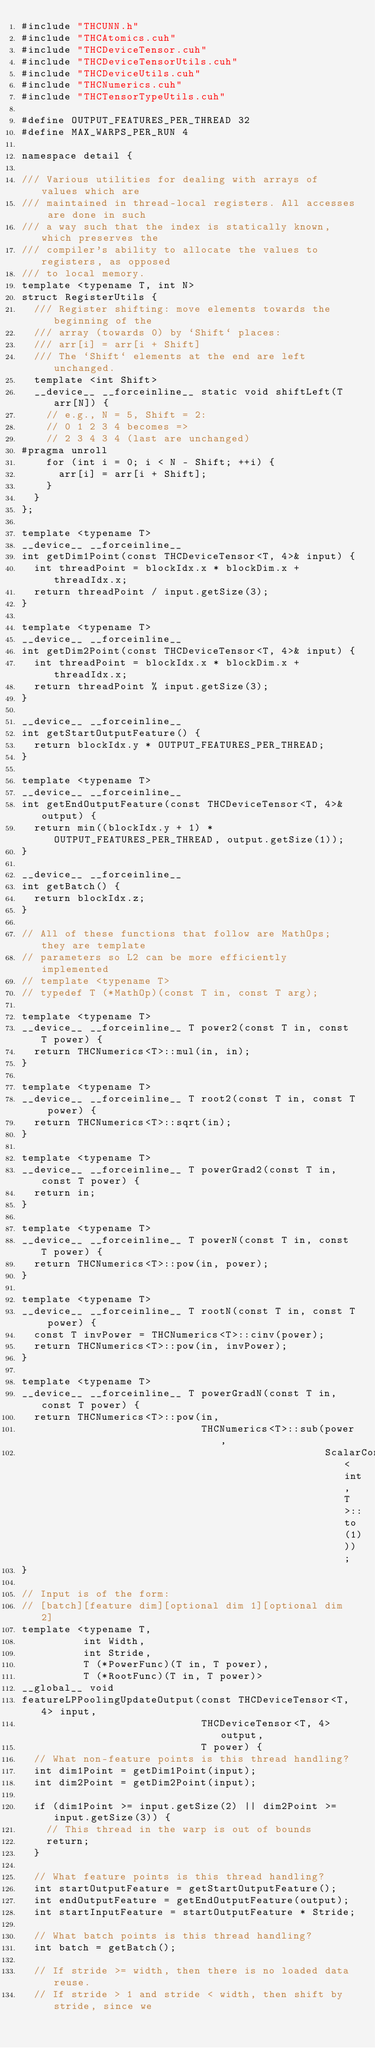<code> <loc_0><loc_0><loc_500><loc_500><_Cuda_>#include "THCUNN.h"
#include "THCAtomics.cuh"
#include "THCDeviceTensor.cuh"
#include "THCDeviceTensorUtils.cuh"
#include "THCDeviceUtils.cuh"
#include "THCNumerics.cuh"
#include "THCTensorTypeUtils.cuh"

#define OUTPUT_FEATURES_PER_THREAD 32
#define MAX_WARPS_PER_RUN 4

namespace detail {

/// Various utilities for dealing with arrays of values which are
/// maintained in thread-local registers. All accesses are done in such
/// a way such that the index is statically known, which preserves the
/// compiler's ability to allocate the values to registers, as opposed
/// to local memory.
template <typename T, int N>
struct RegisterUtils {
  /// Register shifting: move elements towards the beginning of the
  /// array (towards 0) by `Shift` places:
  /// arr[i] = arr[i + Shift]
  /// The `Shift` elements at the end are left unchanged.
  template <int Shift>
  __device__ __forceinline__ static void shiftLeft(T arr[N]) {
    // e.g., N = 5, Shift = 2:
    // 0 1 2 3 4 becomes =>
    // 2 3 4 3 4 (last are unchanged)
#pragma unroll
    for (int i = 0; i < N - Shift; ++i) {
      arr[i] = arr[i + Shift];
    }
  }
};

template <typename T>
__device__ __forceinline__
int getDim1Point(const THCDeviceTensor<T, 4>& input) {
  int threadPoint = blockIdx.x * blockDim.x + threadIdx.x;
  return threadPoint / input.getSize(3);
}

template <typename T>
__device__ __forceinline__
int getDim2Point(const THCDeviceTensor<T, 4>& input) {
  int threadPoint = blockIdx.x * blockDim.x + threadIdx.x;
  return threadPoint % input.getSize(3);
}

__device__ __forceinline__
int getStartOutputFeature() {
  return blockIdx.y * OUTPUT_FEATURES_PER_THREAD;
}

template <typename T>
__device__ __forceinline__
int getEndOutputFeature(const THCDeviceTensor<T, 4>& output) {
  return min((blockIdx.y + 1) * OUTPUT_FEATURES_PER_THREAD, output.getSize(1));
}

__device__ __forceinline__
int getBatch() {
  return blockIdx.z;
}

// All of these functions that follow are MathOps; they are template
// parameters so L2 can be more efficiently implemented
// template <typename T>
// typedef T (*MathOp)(const T in, const T arg);

template <typename T>
__device__ __forceinline__ T power2(const T in, const T power) {
  return THCNumerics<T>::mul(in, in);
}

template <typename T>
__device__ __forceinline__ T root2(const T in, const T power) {
  return THCNumerics<T>::sqrt(in);
}

template <typename T>
__device__ __forceinline__ T powerGrad2(const T in, const T power) {
  return in;
}

template <typename T>
__device__ __forceinline__ T powerN(const T in, const T power) {
  return THCNumerics<T>::pow(in, power);
}

template <typename T>
__device__ __forceinline__ T rootN(const T in, const T power) {
  const T invPower = THCNumerics<T>::cinv(power);
  return THCNumerics<T>::pow(in, invPower);
}

template <typename T>
__device__ __forceinline__ T powerGradN(const T in, const T power) {
  return THCNumerics<T>::pow(in,
                             THCNumerics<T>::sub(power,
                                                 ScalarConvert<int, T>::to(1)));
}

// Input is of the form:
// [batch][feature dim][optional dim 1][optional dim 2]
template <typename T,
          int Width,
          int Stride,
          T (*PowerFunc)(T in, T power),
          T (*RootFunc)(T in, T power)>
__global__ void
featureLPPoolingUpdateOutput(const THCDeviceTensor<T, 4> input,
                             THCDeviceTensor<T, 4> output,
                             T power) {
  // What non-feature points is this thread handling?
  int dim1Point = getDim1Point(input);
  int dim2Point = getDim2Point(input);

  if (dim1Point >= input.getSize(2) || dim2Point >= input.getSize(3)) {
    // This thread in the warp is out of bounds
    return;
  }

  // What feature points is this thread handling?
  int startOutputFeature = getStartOutputFeature();
  int endOutputFeature = getEndOutputFeature(output);
  int startInputFeature = startOutputFeature * Stride;

  // What batch points is this thread handling?
  int batch = getBatch();

  // If stride >= width, then there is no loaded data reuse.
  // If stride > 1 and stride < width, then shift by stride, since we</code> 